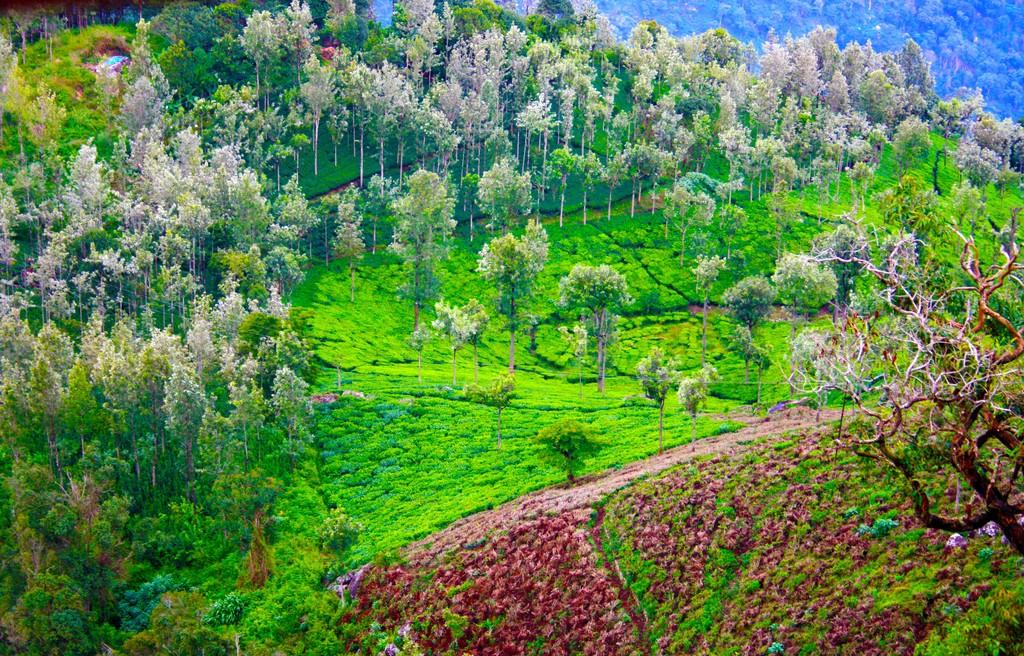What type of vegetation can be seen in the image? There are trees and plants visible in the image. Where are the plants located in the image? The plants are at the bottom of the image. What is the surface visible in the image? There is ground visible in the image. What type of pipe can be seen in the image? There is no pipe present in the image. How does the grass in the image affect the growth of the trees? There is no grass visible in the image, so it cannot affect the growth of the trees. 